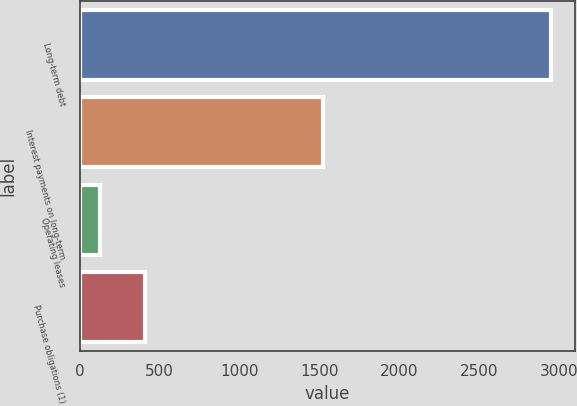<chart> <loc_0><loc_0><loc_500><loc_500><bar_chart><fcel>Long-term debt<fcel>Interest payments on long-term<fcel>Operating leases<fcel>Purchase obligations (1)<nl><fcel>2951<fcel>1521<fcel>129<fcel>411.2<nl></chart> 